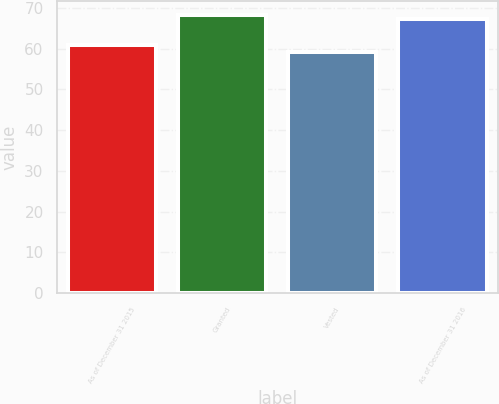Convert chart. <chart><loc_0><loc_0><loc_500><loc_500><bar_chart><fcel>As of December 31 2015<fcel>Granted<fcel>Vested<fcel>As of December 31 2016<nl><fcel>60.78<fcel>68.19<fcel>59.13<fcel>67.32<nl></chart> 